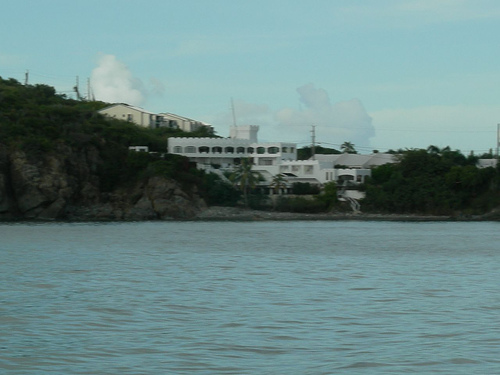<image>
Is the sky behind the building? Yes. From this viewpoint, the sky is positioned behind the building, with the building partially or fully occluding the sky. 